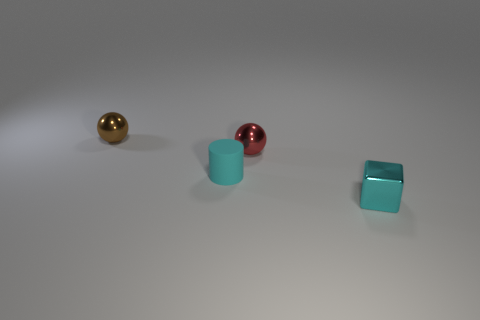Add 1 metallic balls. How many objects exist? 5 Subtract 1 balls. How many balls are left? 1 Subtract all cubes. How many objects are left? 3 Subtract all red spheres. Subtract all small brown metal objects. How many objects are left? 2 Add 2 red metallic balls. How many red metallic balls are left? 3 Add 4 brown metal objects. How many brown metal objects exist? 5 Subtract all red spheres. How many spheres are left? 1 Subtract 0 purple cubes. How many objects are left? 4 Subtract all blue balls. Subtract all brown cylinders. How many balls are left? 2 Subtract all green balls. How many green cylinders are left? 0 